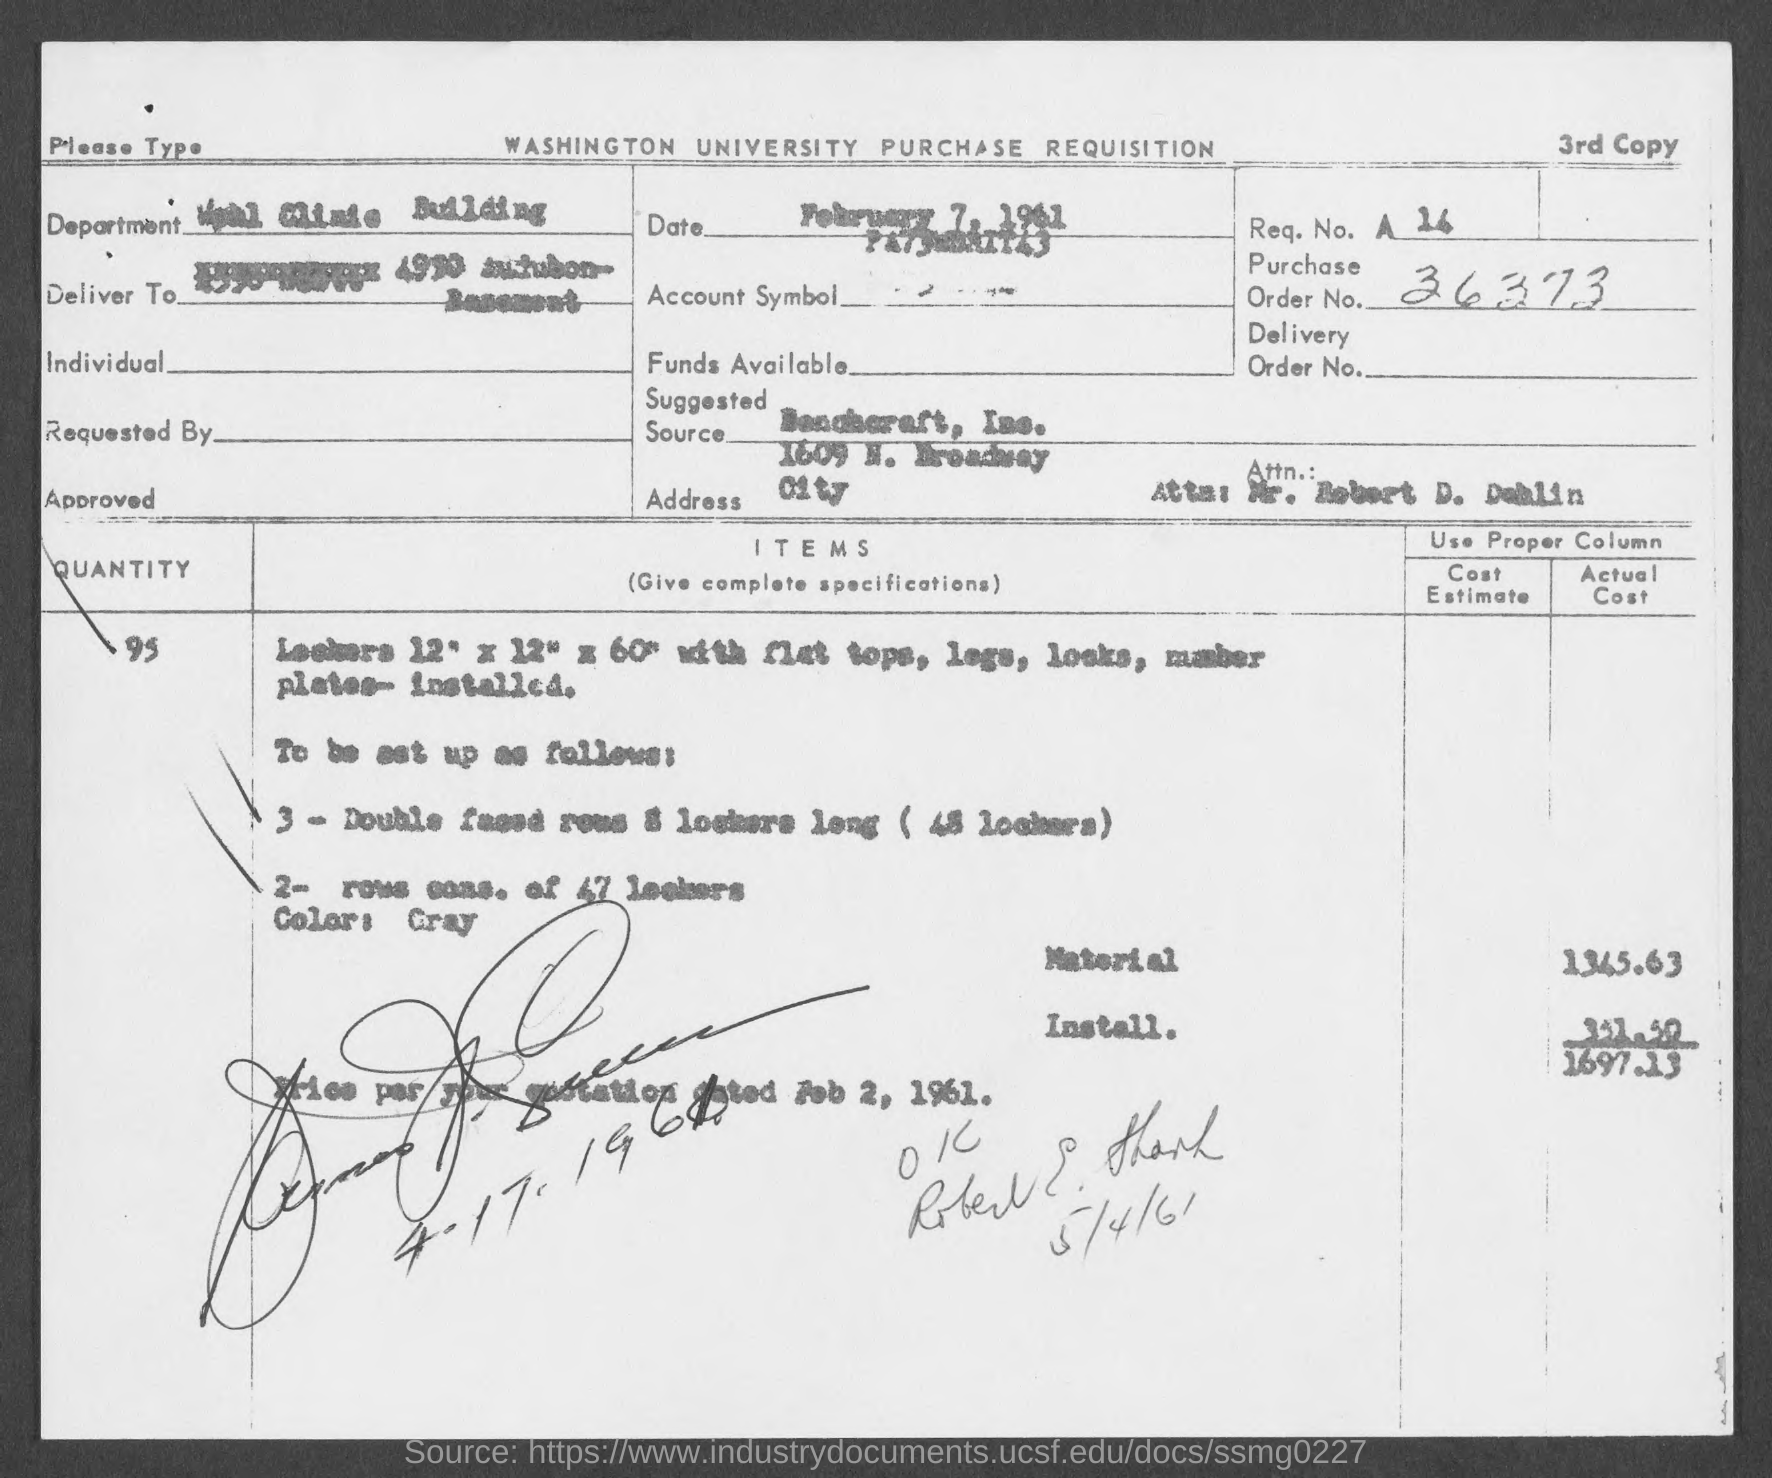Indicate a few pertinent items in this graphic. The actual cost of the material mentioned on the given page is 1345.63... 